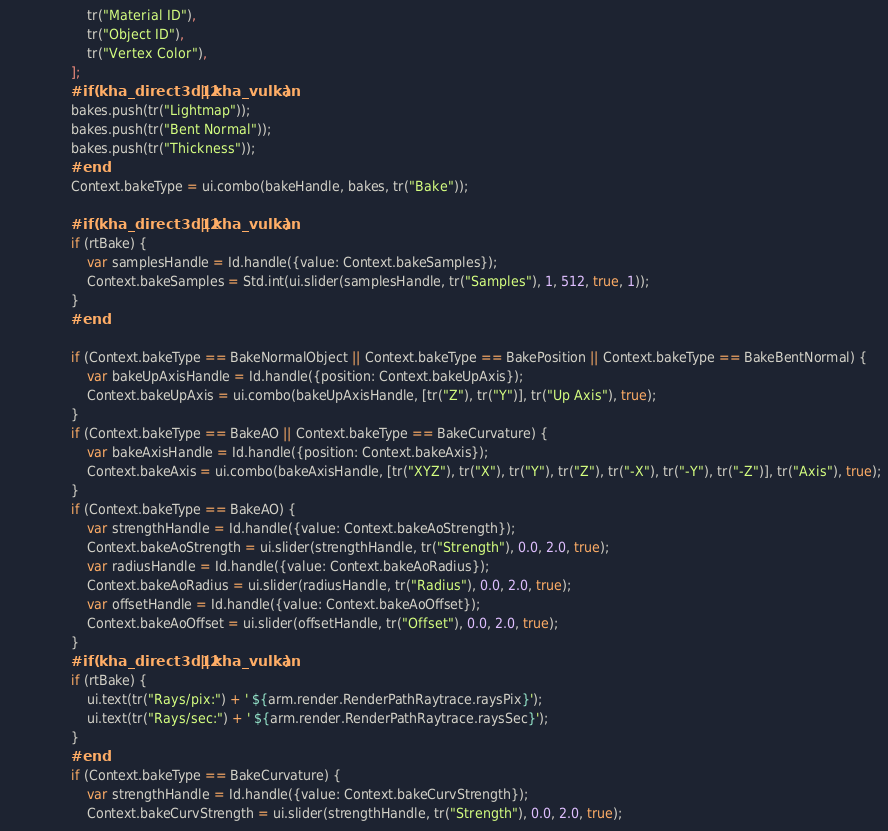Convert code to text. <code><loc_0><loc_0><loc_500><loc_500><_Haxe_>					tr("Material ID"),
					tr("Object ID"),
					tr("Vertex Color"),
				];
				#if (kha_direct3d12 || kha_vulkan)
				bakes.push(tr("Lightmap"));
				bakes.push(tr("Bent Normal"));
				bakes.push(tr("Thickness"));
				#end
				Context.bakeType = ui.combo(bakeHandle, bakes, tr("Bake"));

				#if (kha_direct3d12 || kha_vulkan)
				if (rtBake) {
					var samplesHandle = Id.handle({value: Context.bakeSamples});
					Context.bakeSamples = Std.int(ui.slider(samplesHandle, tr("Samples"), 1, 512, true, 1));
				}
				#end

				if (Context.bakeType == BakeNormalObject || Context.bakeType == BakePosition || Context.bakeType == BakeBentNormal) {
					var bakeUpAxisHandle = Id.handle({position: Context.bakeUpAxis});
					Context.bakeUpAxis = ui.combo(bakeUpAxisHandle, [tr("Z"), tr("Y")], tr("Up Axis"), true);
				}
				if (Context.bakeType == BakeAO || Context.bakeType == BakeCurvature) {
					var bakeAxisHandle = Id.handle({position: Context.bakeAxis});
					Context.bakeAxis = ui.combo(bakeAxisHandle, [tr("XYZ"), tr("X"), tr("Y"), tr("Z"), tr("-X"), tr("-Y"), tr("-Z")], tr("Axis"), true);
				}
				if (Context.bakeType == BakeAO) {
					var strengthHandle = Id.handle({value: Context.bakeAoStrength});
					Context.bakeAoStrength = ui.slider(strengthHandle, tr("Strength"), 0.0, 2.0, true);
					var radiusHandle = Id.handle({value: Context.bakeAoRadius});
					Context.bakeAoRadius = ui.slider(radiusHandle, tr("Radius"), 0.0, 2.0, true);
					var offsetHandle = Id.handle({value: Context.bakeAoOffset});
					Context.bakeAoOffset = ui.slider(offsetHandle, tr("Offset"), 0.0, 2.0, true);
				}
				#if (kha_direct3d12 || kha_vulkan)
				if (rtBake) {
					ui.text(tr("Rays/pix:") + ' ${arm.render.RenderPathRaytrace.raysPix}');
					ui.text(tr("Rays/sec:") + ' ${arm.render.RenderPathRaytrace.raysSec}');
				}
				#end
				if (Context.bakeType == BakeCurvature) {
					var strengthHandle = Id.handle({value: Context.bakeCurvStrength});
					Context.bakeCurvStrength = ui.slider(strengthHandle, tr("Strength"), 0.0, 2.0, true);</code> 